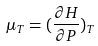<formula> <loc_0><loc_0><loc_500><loc_500>\mu _ { T } = ( \frac { \partial H } { \partial P } ) _ { T }</formula> 